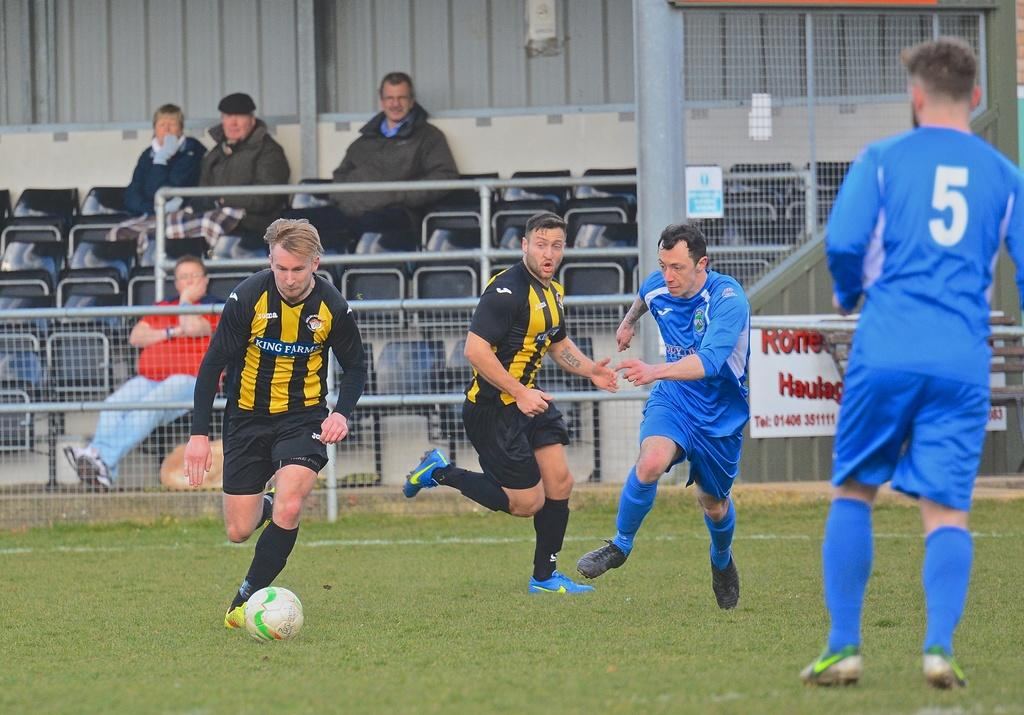<image>
Relay a brief, clear account of the picture shown. A soccer player in a yellow and black striped shirt from King Farms. 